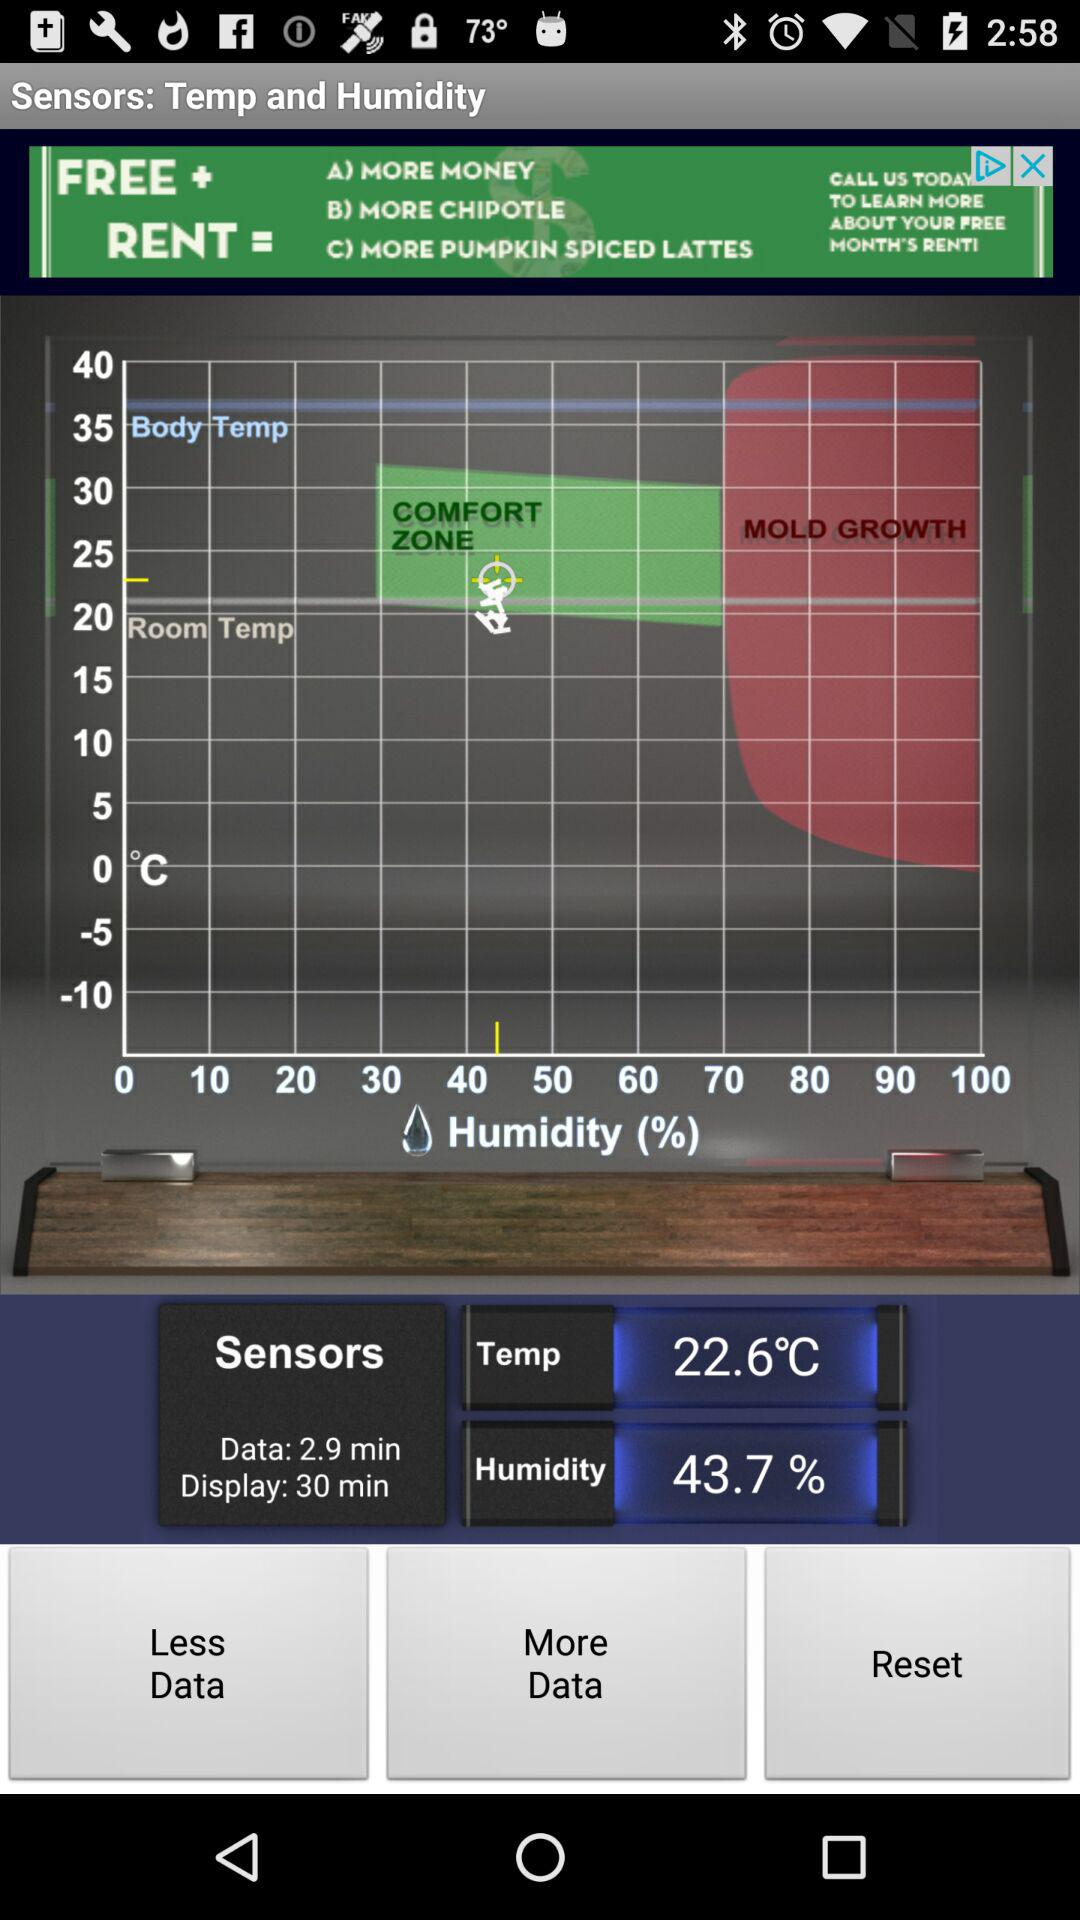What is the time duration of "Data"? The time duration is 2.9 minutes. 